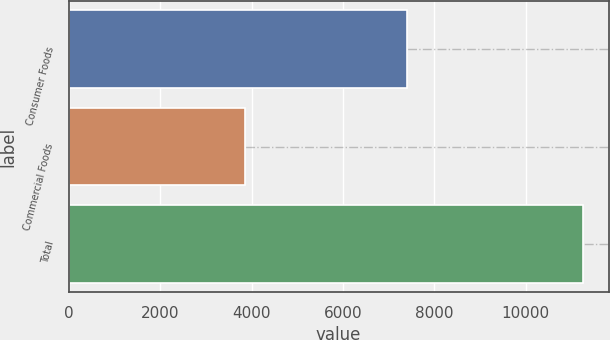Convert chart. <chart><loc_0><loc_0><loc_500><loc_500><bar_chart><fcel>Consumer Foods<fcel>Commercial Foods<fcel>Total<nl><fcel>7400<fcel>3848<fcel>11248<nl></chart> 